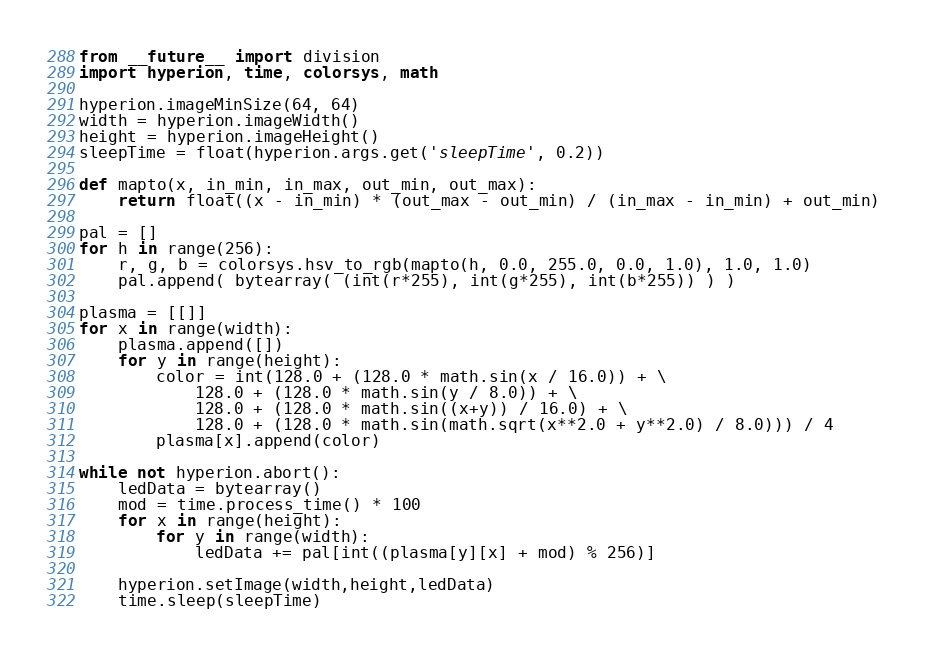<code> <loc_0><loc_0><loc_500><loc_500><_Python_>from __future__ import division
import hyperion, time, colorsys, math

hyperion.imageMinSize(64, 64)
width = hyperion.imageWidth()
height = hyperion.imageHeight()
sleepTime = float(hyperion.args.get('sleepTime', 0.2))

def mapto(x, in_min, in_max, out_min, out_max):
	return float((x - in_min) * (out_max - out_min) / (in_max - in_min) + out_min)

pal = []
for h in range(256):
	r, g, b = colorsys.hsv_to_rgb(mapto(h, 0.0, 255.0, 0.0, 1.0), 1.0, 1.0)
	pal.append( bytearray( (int(r*255), int(g*255), int(b*255)) ) )

plasma = [[]]
for x in range(width):
	plasma.append([])
	for y in range(height):
		color = int(128.0 + (128.0 * math.sin(x / 16.0)) + \
			128.0 + (128.0 * math.sin(y / 8.0)) + \
			128.0 + (128.0 * math.sin((x+y)) / 16.0) + \
			128.0 + (128.0 * math.sin(math.sqrt(x**2.0 + y**2.0) / 8.0))) / 4
		plasma[x].append(color)

while not hyperion.abort():
	ledData = bytearray()
	mod = time.process_time() * 100
	for x in range(height):
		for y in range(width):
			ledData += pal[int((plasma[y][x] + mod) % 256)]

	hyperion.setImage(width,height,ledData)
	time.sleep(sleepTime)

</code> 